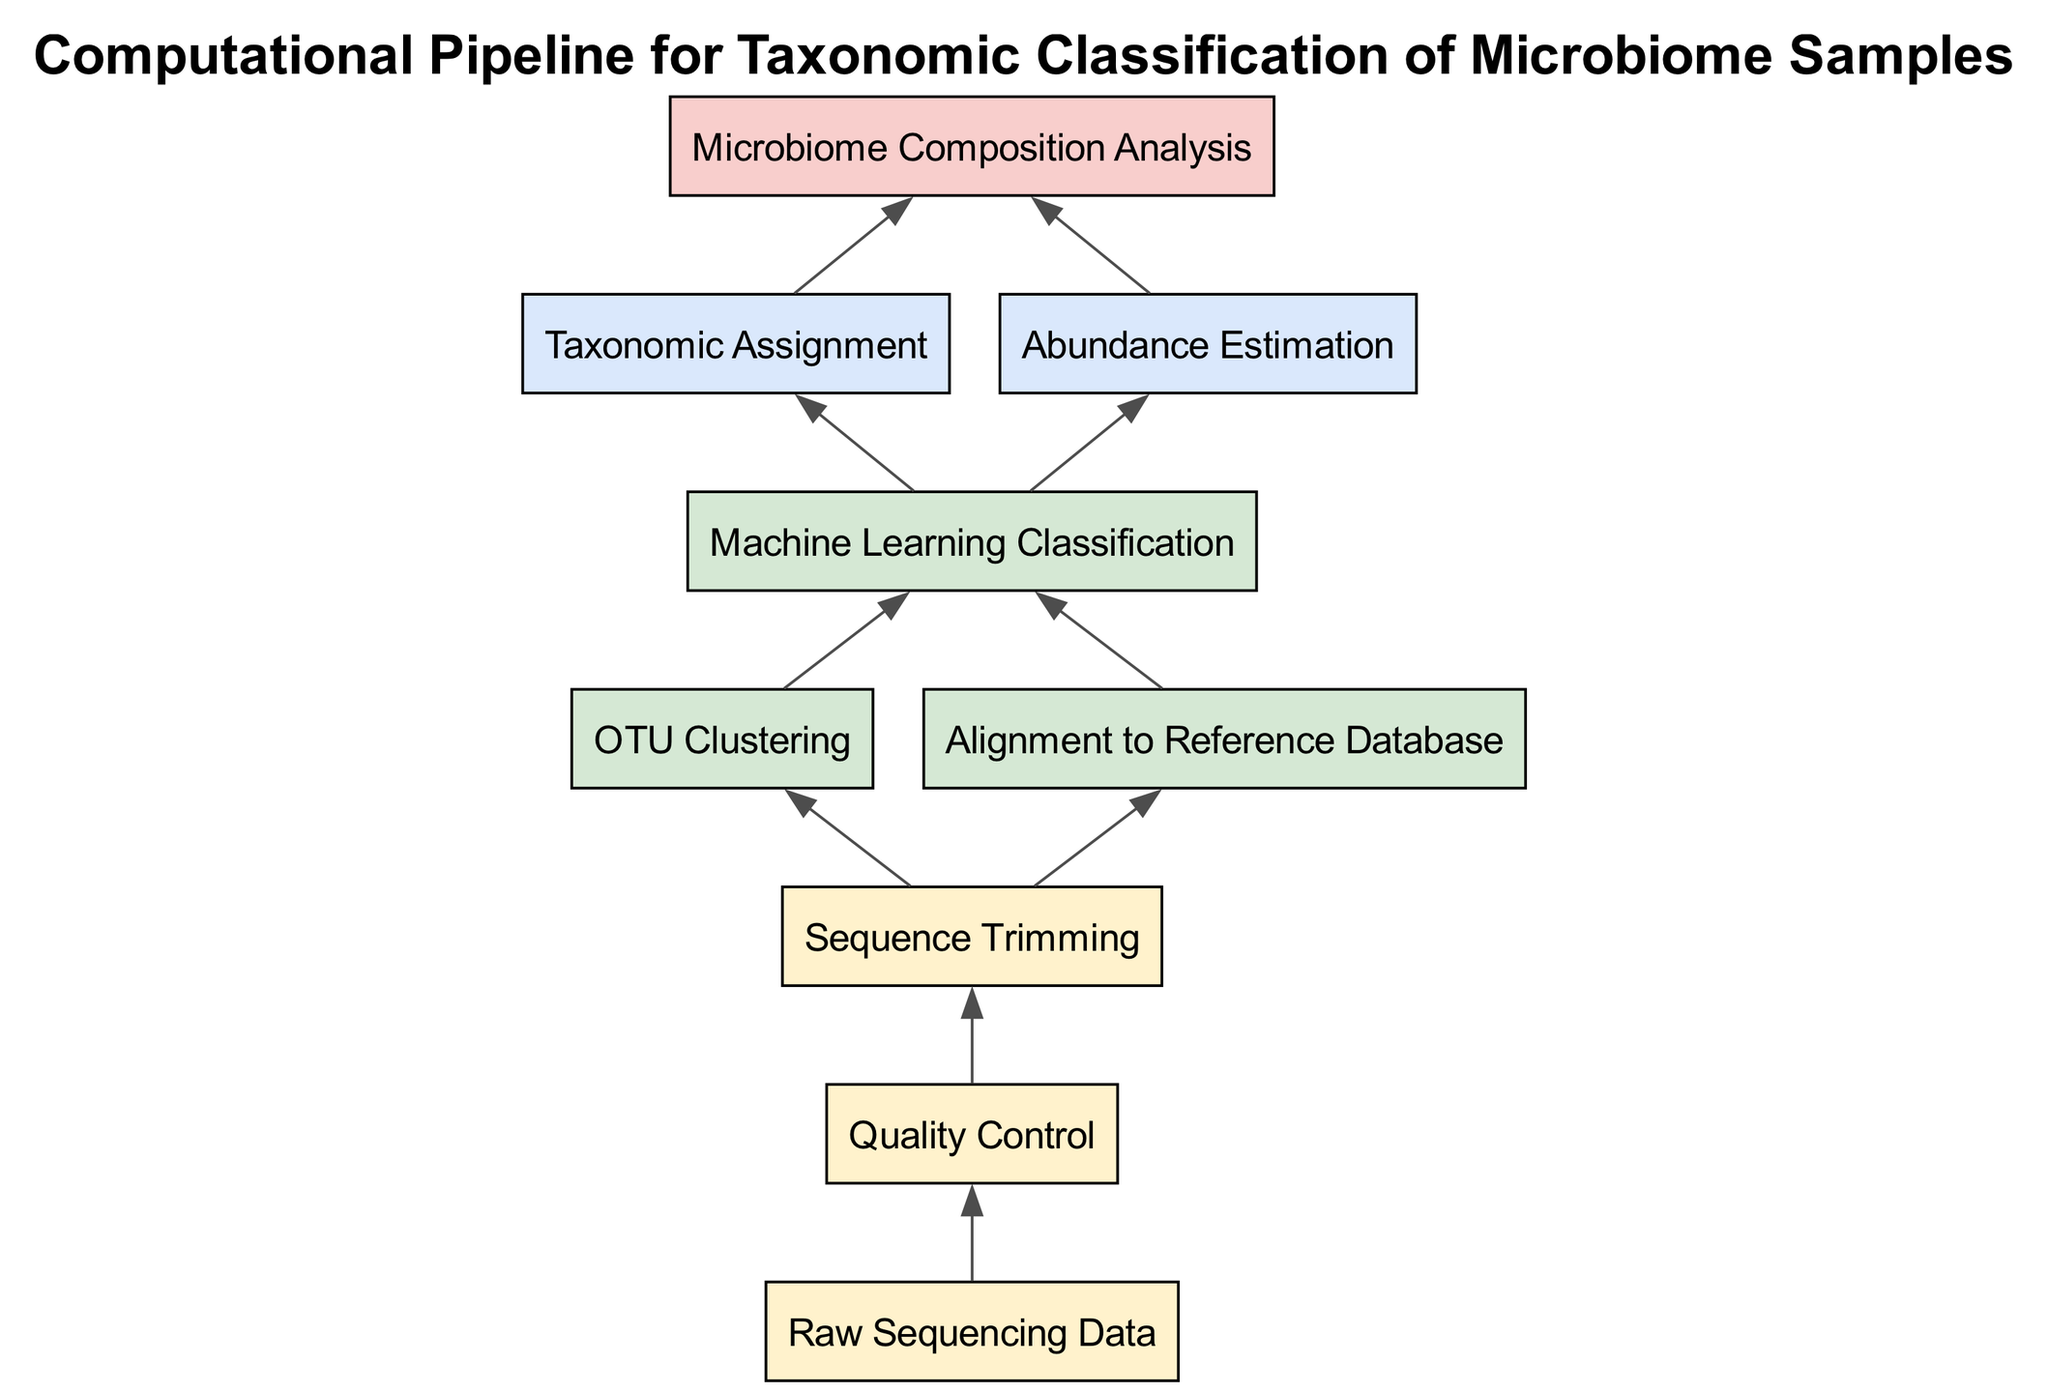What is the final node in the diagram? The final node is "Microbiome Composition Analysis", located at the top of the flow chart as the endpoint of the entire process.
Answer: Microbiome Composition Analysis How many bottom nodes are there? The diagram presents three bottom nodes, which include "Raw Sequencing Data", "Quality Control", and "Sequence Trimming".
Answer: 3 What is the first step in the flow chart? The first step, represented by the bottom node, is "Raw Sequencing Data", which initiates the computational pipeline.
Answer: Raw Sequencing Data Which nodes lead to "Machine Learning Classification"? The nodes "OTU Clustering" and "Alignment to Reference Database" both connect to "Machine Learning Classification", showing they must be completed to reach this stage.
Answer: OTU Clustering, Alignment to Reference Database What nodes contribute to "Taxonomic Assignment"? "Taxonomic Assignment" is fed by the "Machine Learning Classification" node, indicating this step relies on the results from machine learning.
Answer: Machine Learning Classification How many edges are in the diagram? The diagram contains ten connections (or edges), connecting various nodes in the workflow of taxonomic classification.
Answer: 10 What node must be completed after "Sequence Trimming"? After "Sequence Trimming", the next processes are "OTU Clustering" and "Alignment to Reference Database", both of which are simultaneous tasks following this step.
Answer: OTU Clustering, Alignment to Reference Database Which top node also connects to "Microbiome Composition Analysis"? Both "Taxonomic Assignment" and "Abundance Estimation" connect to "Microbiome Composition Analysis", indicating their significance in the final analysis.
Answer: Taxonomic Assignment, Abundance Estimation What type of flow chart is this? This diagram is a Bottom Up Flow Chart, as it organizes the process from bottom nodes to a final output node at the top.
Answer: Bottom Up Flow Chart 